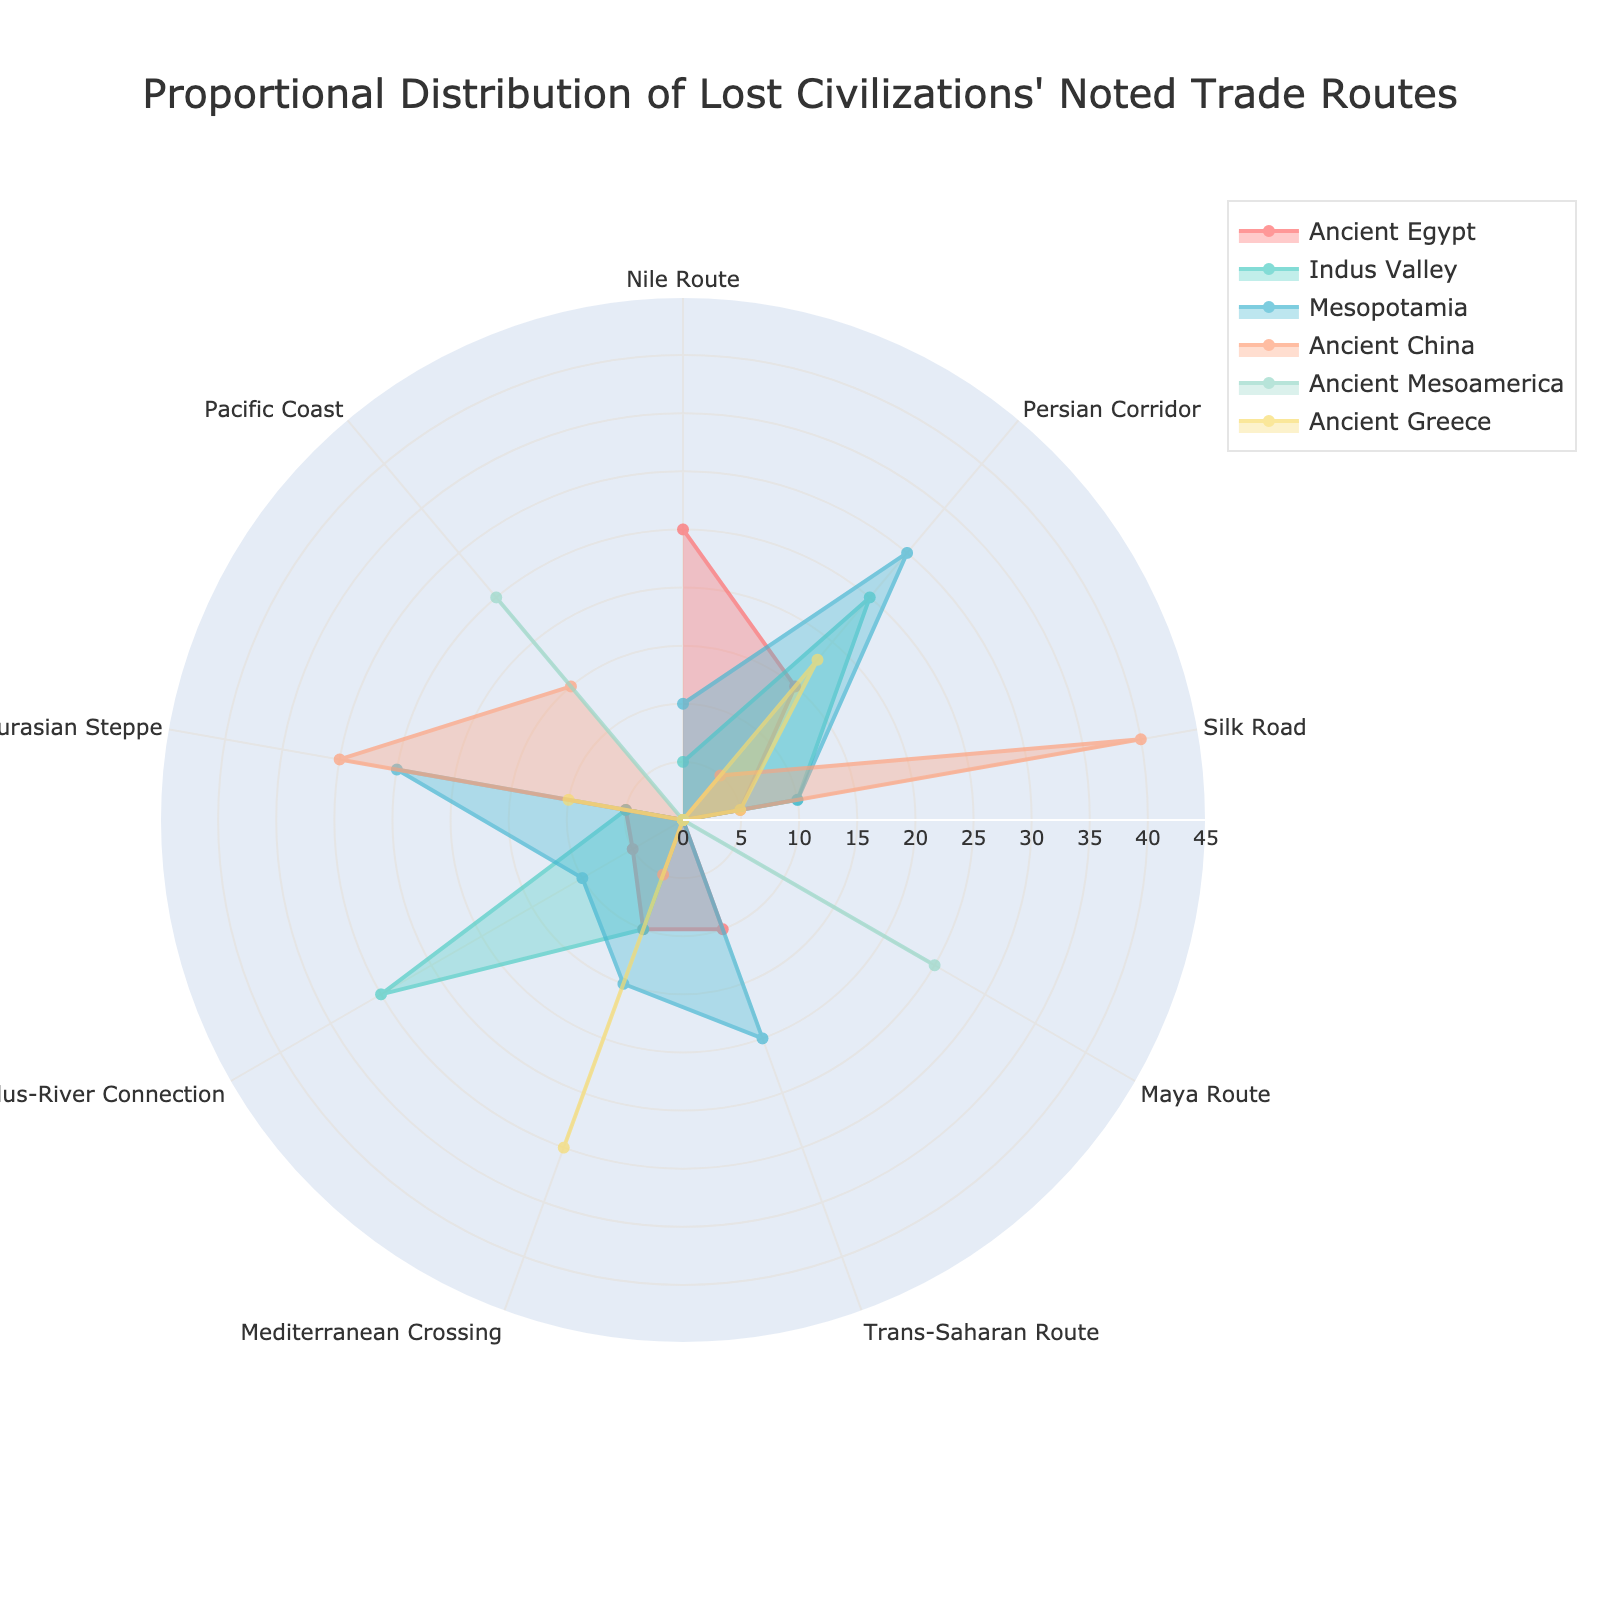What is the title of the radar chart? The title is usually positioned at the top of the chart and is clearly marked to describe the content. Here, you should look at the top of the diagram.
Answer: Proportional Distribution of Lost Civilizations' Noted Trade Routes Which civilization has the highest proportion in the Indus-River Connection trade route? To determine this, examine the section labeled "Indus-River Connection" and find the longest segment corresponding to a civilization.
Answer: Indus Valley What are the two civilizations with the highest proportions on the Persian Corridor? Look at the "Persian Corridor" section and identify the two largest segments allocated to any civilizations.
Answer: Mesopotamia and Indus Valley Which civilization has the smallest representation on the Nile Route? Find the Nile Route section and identify the civilization whose segment is either nonexistent or the smallest.
Answer: Ancient China How does the representation of Ancient Mesoamerica on the Maya Route compare to other civilizations? Examine the Maya Route section. Ancient Mesoamerica's segment can be compared to non-existent segments of other civilizations.
Answer: Ancient Mesoamerica is the only civilization with representation What is the average proportion of nodes for Ancient Greece across all trade routes? Sum the values for Ancient Greece across all trade routes and divide by the number of different trade routes.
Answer: (0 + 18 + 5 + 0 + 0 + 30 + 0 + 10 + 0) / 9 = 63 / 9 = 7 Among the Silk Road, which two civilizations have an equal proportion? Look at the Silk Road section and identify which two civilizations have segments of the same length.
Answer: Ancient Egypt and Mesopotamia Which trade route shows the greatest diversity in the number of civilizations participating? Diversity can be judged by the presence of many civilizations, so identify which route has segments belonging to more different civilizations.
Answer: Persian Corridor Compare the proportions of Ancient Egypt and Ancient Greece on the Mediterranean Crossing. Which is higher? Find the Mediterranean Crossing section and compare the length of the segments for Ancient Egypt and Ancient Greece.
Answer: Ancient Greece 